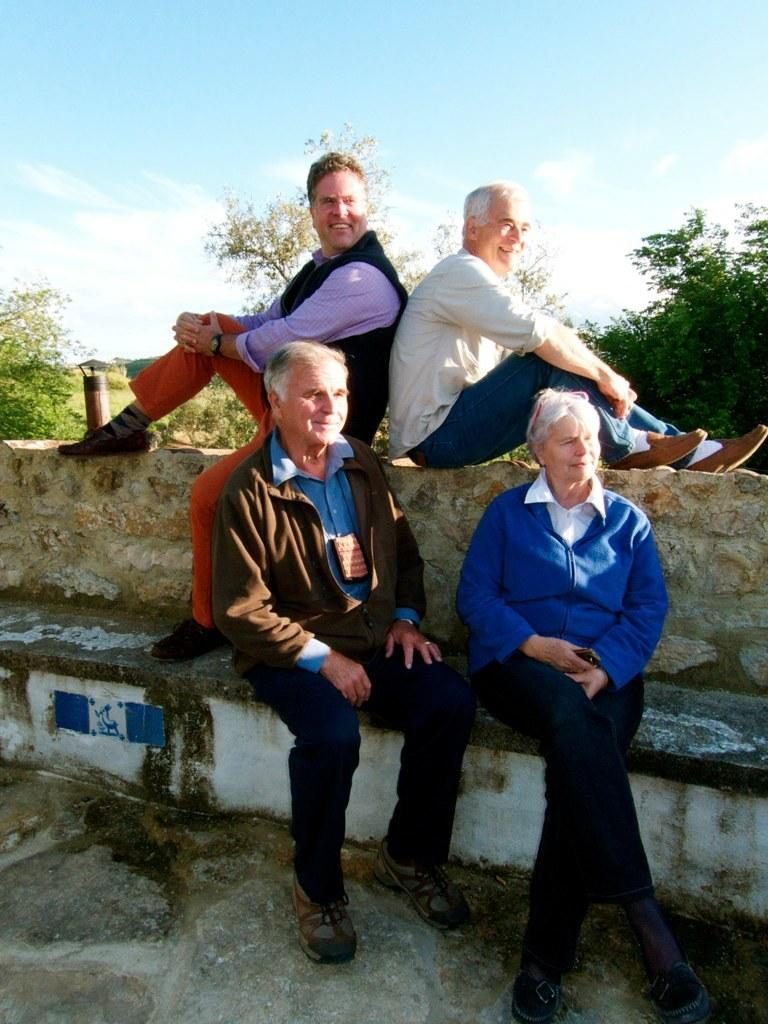Who is in the image? There is a group of old friends in the image. Where are the friends sitting? The friends are sitting on a small wall. What is the mood of the friends in the image? The friends are smiling, which suggests a positive mood. What can be seen in the background of the image? There are many trees in the background of the image. What type of spark can be seen coming from the curtain in the image? There is no curtain or spark present in the image. 